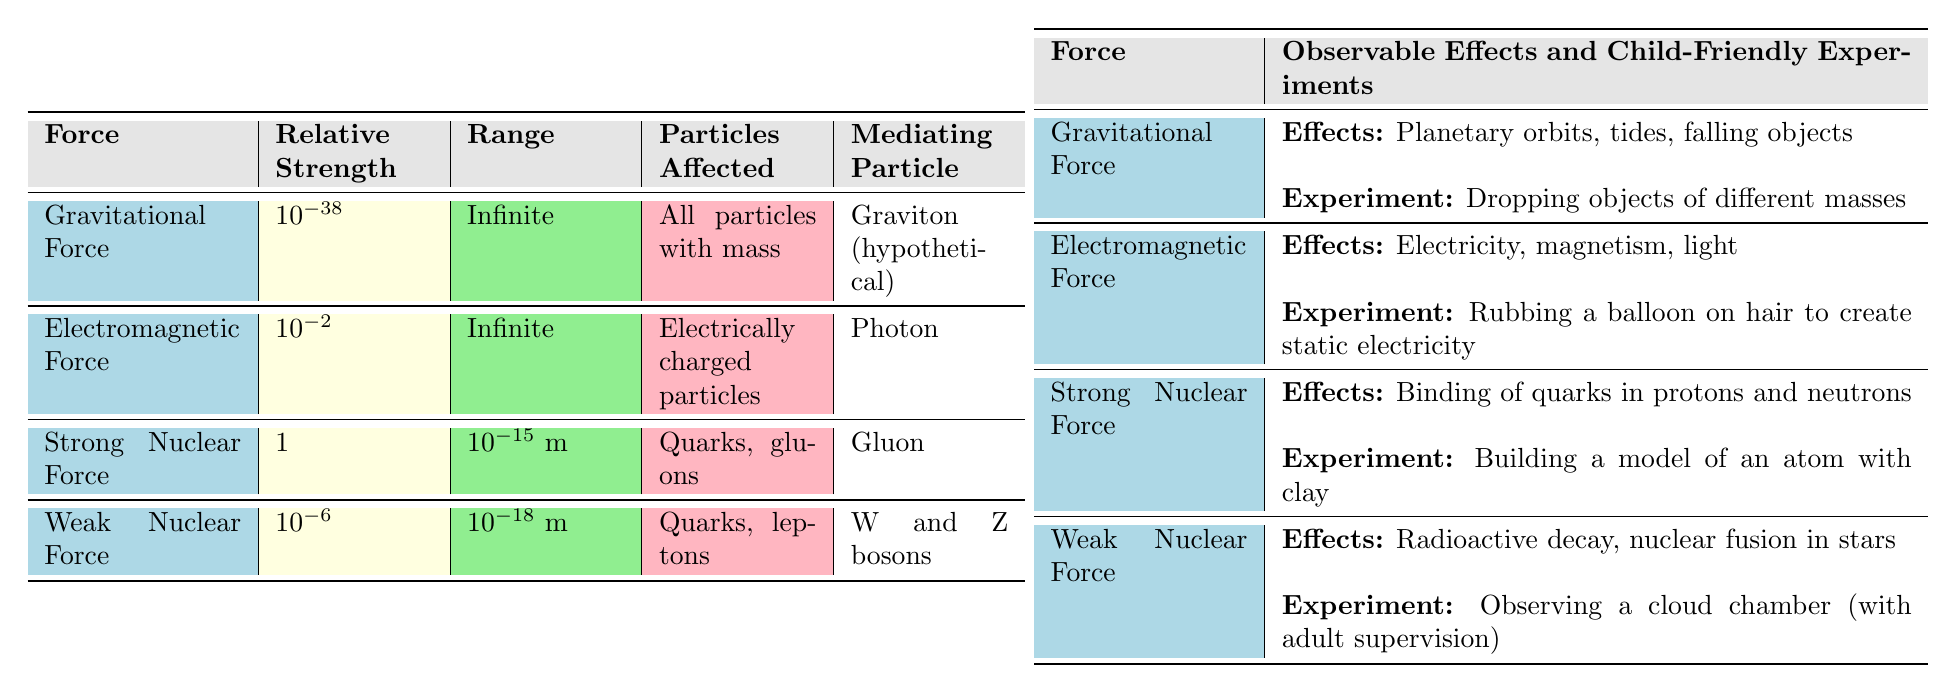What is the relative strength of the Strong Nuclear Force? In the table, the relative strength of the Strong Nuclear Force is explicitly listed as 1.
Answer: 1 What particles are affected by the Gravitational Force? The table indicates that the Gravitational Force affects all particles with mass.
Answer: All particles with mass Which force has a range of 1e-18 meters? By examining the table, the Weak Nuclear Force is indicated to have a range of 1e-18 meters.
Answer: Weak Nuclear Force Does the Electromagnetic Force have a finite range? The table shows that the range of the Electromagnetic Force is infinite, therefore it does not have a finite range.
Answer: No What is the observable effect of the Weak Nuclear Force? The table states that the observable effects of the Weak Nuclear Force include radioactive decay and nuclear fusion in stars.
Answer: Radioactive decay and nuclear fusion in stars Which force has the weakest relative strength and what is that value? The table indicates that the Gravitational Force has the weakest relative strength at 1e-38 compared to the other forces.
Answer: 1e-38 Compare the ranges of the Strong Nuclear Force and the Weak Nuclear Force. The table shows the range of the Strong Nuclear Force is 1e-15 meters and the Weak Nuclear Force's range is 1e-18 meters. Therefore, the Strong Nuclear Force has a longer range than the Weak Nuclear Force.
Answer: Strong Nuclear Force has a longer range What is the mediation particle for the Gravitational Force and is it hypothetical? The table describes the mediating particle for the Gravitational Force as the Gravton, which is labeled as hypothetical. Thus, it is indeed hypothetical.
Answer: Yes, it is hypothetical What can be concluded about the observable effects of the Strong Nuclear Force? According to the table, the Strong Nuclear Force is responsible for the binding of quarks in protons and neutrons, which is a crucial component of atomic structure.
Answer: Binding of quarks in protons and neutrons List the child-friendly experiment associated with the Electromagnetic Force. The table specifies that the child-friendly experiment related to the Electromagnetic Force is rubbing a balloon on hair to create static electricity.
Answer: Rubbing a balloon on hair to create static electricity 